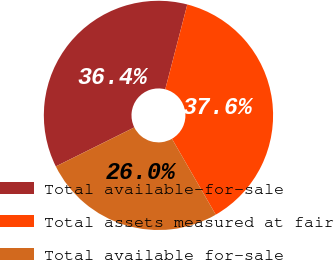<chart> <loc_0><loc_0><loc_500><loc_500><pie_chart><fcel>Total available-for-sale<fcel>Total assets measured at fair<fcel>Total available for-sale<nl><fcel>36.39%<fcel>37.62%<fcel>25.99%<nl></chart> 